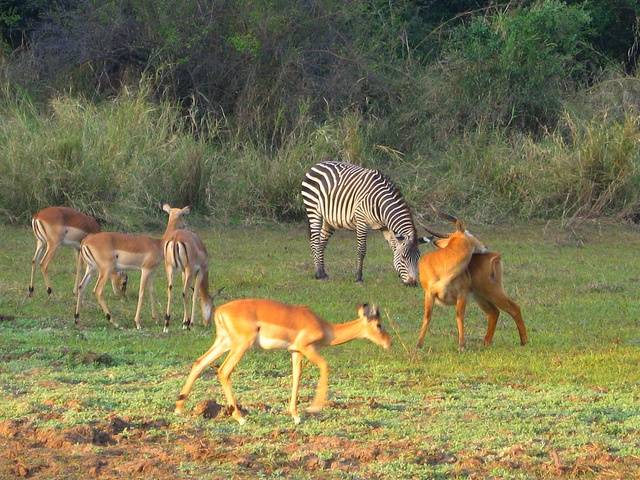Describe the objects in this image and their specific colors. I can see a zebra in black, gray, beige, and tan tones in this image. 